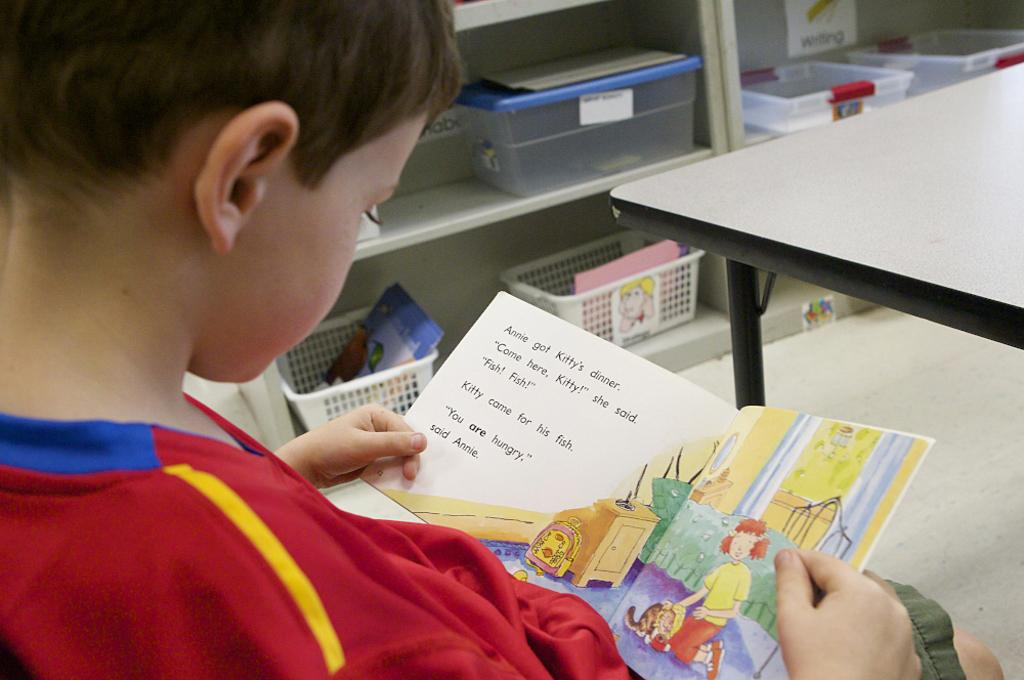What is the child in the image holding? The child is holding a book. Where is the child located in the image? The child is on the left side of the image. What is on the right side of the image? There is a table on the right side of the image. What can be seen in the background of the image? There is a rack with boxes in the background of the image. What is inside the boxes? There are items in the boxes. Can you tell me how many vans are parked near the playground in the image? There is no van or playground present in the image. What type of measuring instrument is being used by the child in the image? There is no measuring instrument visible in the image; the child is holding a book. 